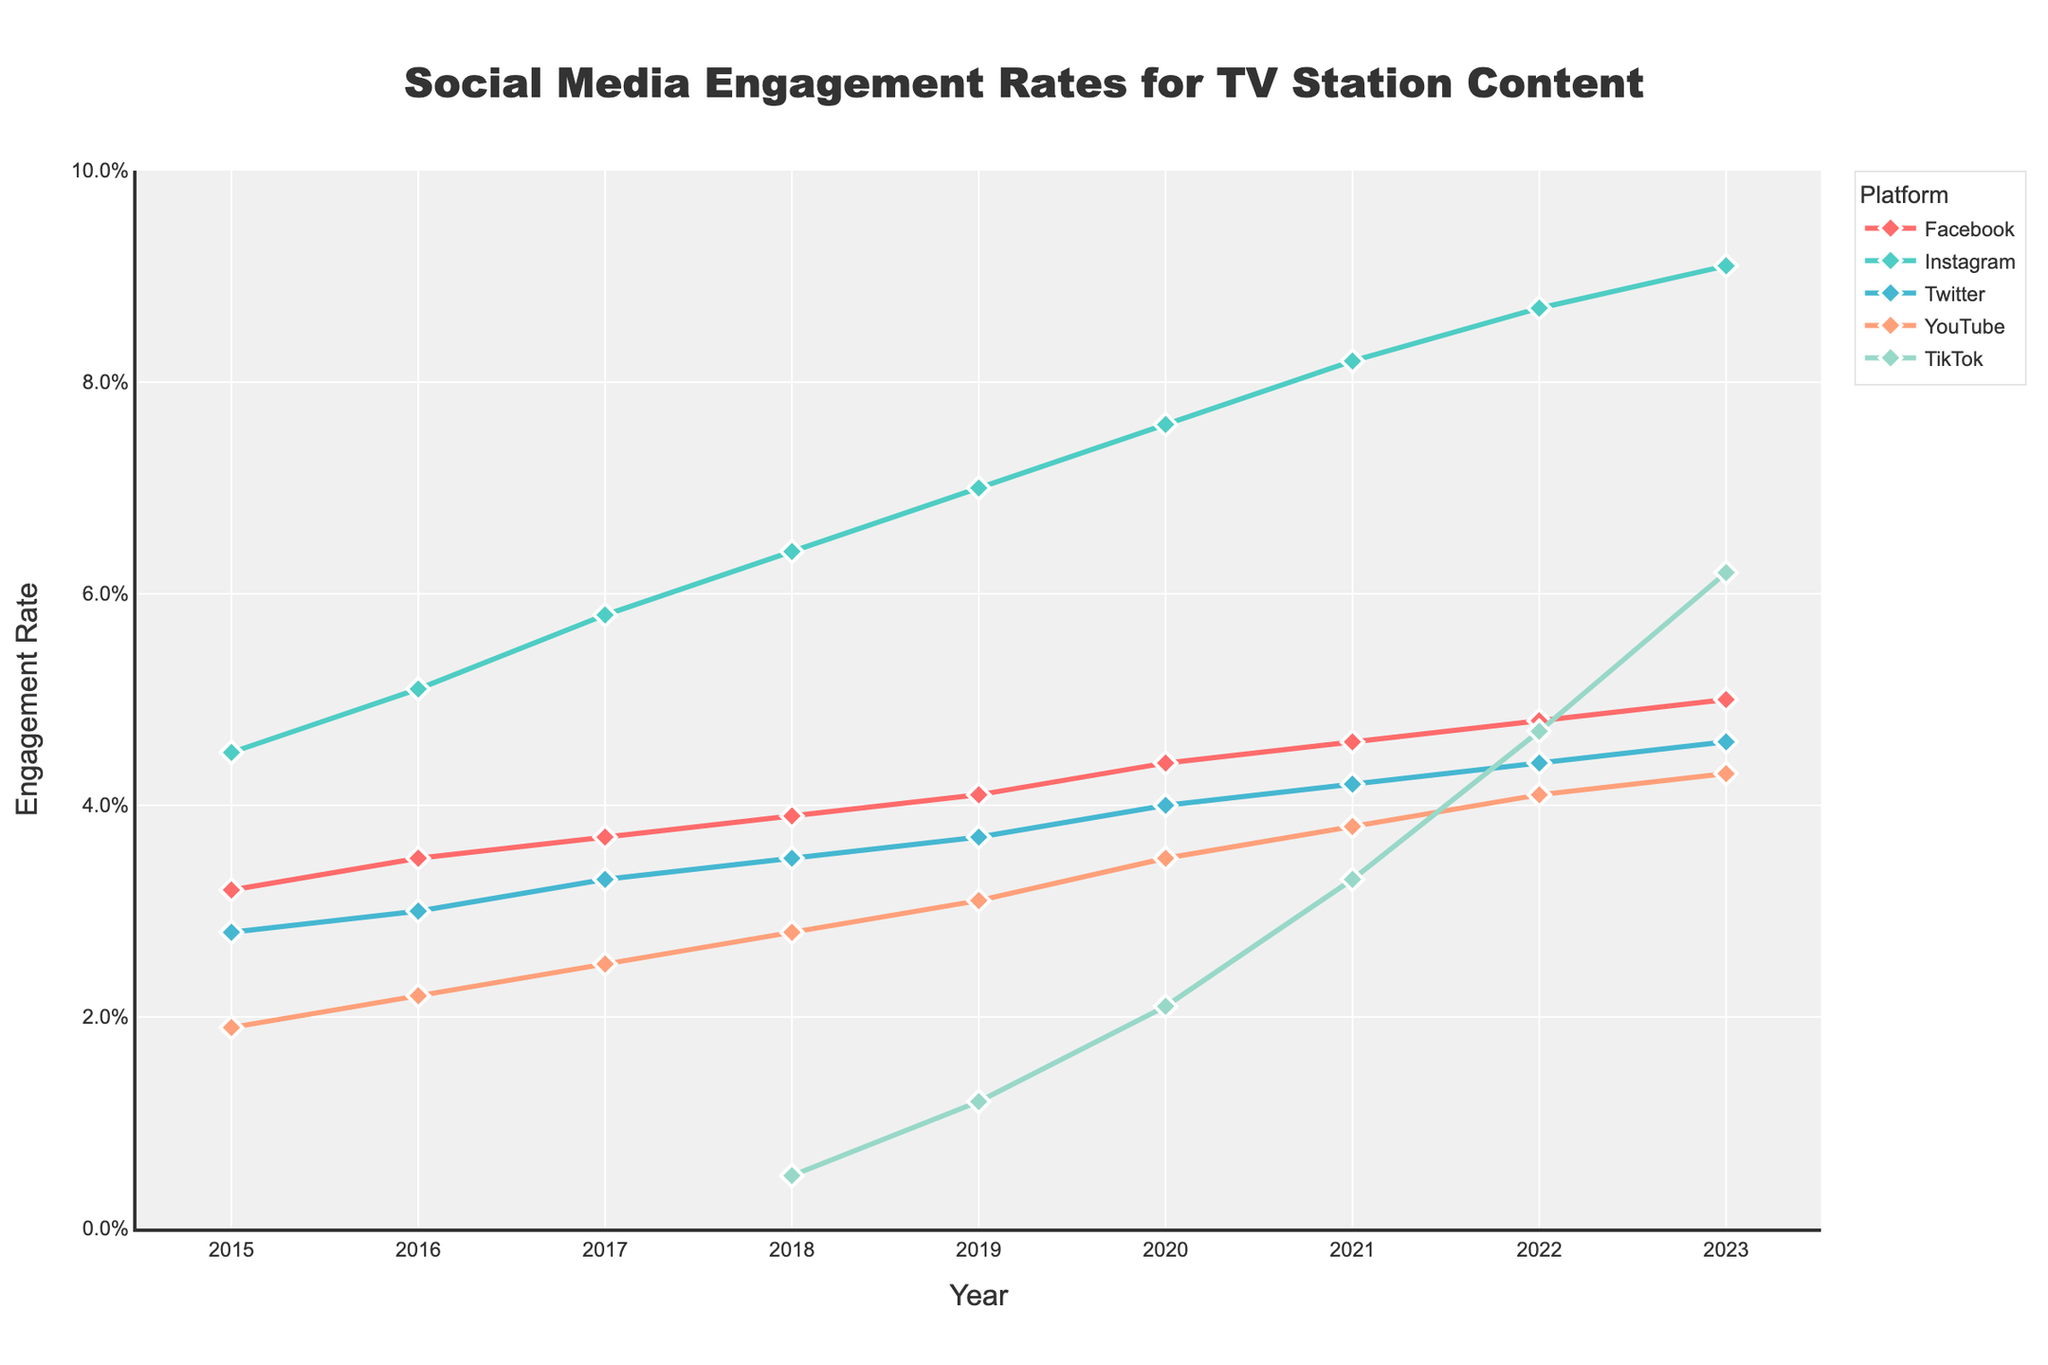What year did TikTok start being included in the data? TikTok engagement rates first appear in 2018. Before 2018, there is an "N/A" indicating it wasn't included in the data. Hence, TikTok is included from 2018 onwards.
Answer: 2018 Between 2015 and 2023, which platform showed the highest increase in engagement rate? By looking at the last year's data point (2023) and the first year's data point (2015) for each platform, we calculate the difference. TikTok went from 0 in 2015 to 6.2% in 2023, making it the platform with the highest increase.
Answer: TikTok In 2020, which platform had the highest engagement rate? Referring to the data points in 2020, Instagram had the highest engagement rate of 7.6%. Other platforms had lower engagement rates compared to Instagram in that year.
Answer: Instagram How did the engagement rate on Facebook change from 2015 to 2023? To find the change, subtract the 2015 engagement rate from the 2023 engagement rate: 5.0% - 3.2% = 1.8%. Therefore, the engagement rate increased by 1.8%.
Answer: Increased by 1.8% Which two platforms had the closest engagement rates in 2022, and what were those rates? Referring to the data for 2022, the engagement rates of Facebook and YouTube are closest: Facebook had 4.8% and YouTube had 4.1%. The difference is 0.7%.
Answer: Facebook (4.8%) and YouTube (4.1%) Which platform experienced the most consistent increase in engagement rate over the years? By visually tracing each line's trend from 2015 to 2023, Instagram shows a consistently smooth line without any dips, indicating the most consistent increase.
Answer: Instagram In which year did Twitter's engagement rate surpass 4%? By looking at the data, Twitter's engagement rate first surpasses 4% in 2020. In 2020, Twitter’s engagement rate increased to 4.0%.
Answer: 2020 What is the average engagement rate on YouTube from 2015 to 2023? Summing up all the yearly engagement rates for YouTube from 2015 to 2023 and then dividing by the number of years (9): (1.9% + 2.2% + 2.5% + 2.8% + 3.1% + 3.5% + 3.8% + 4.1% + 4.3%) / 9 ≈ 3.14%.
Answer: 3.14% 